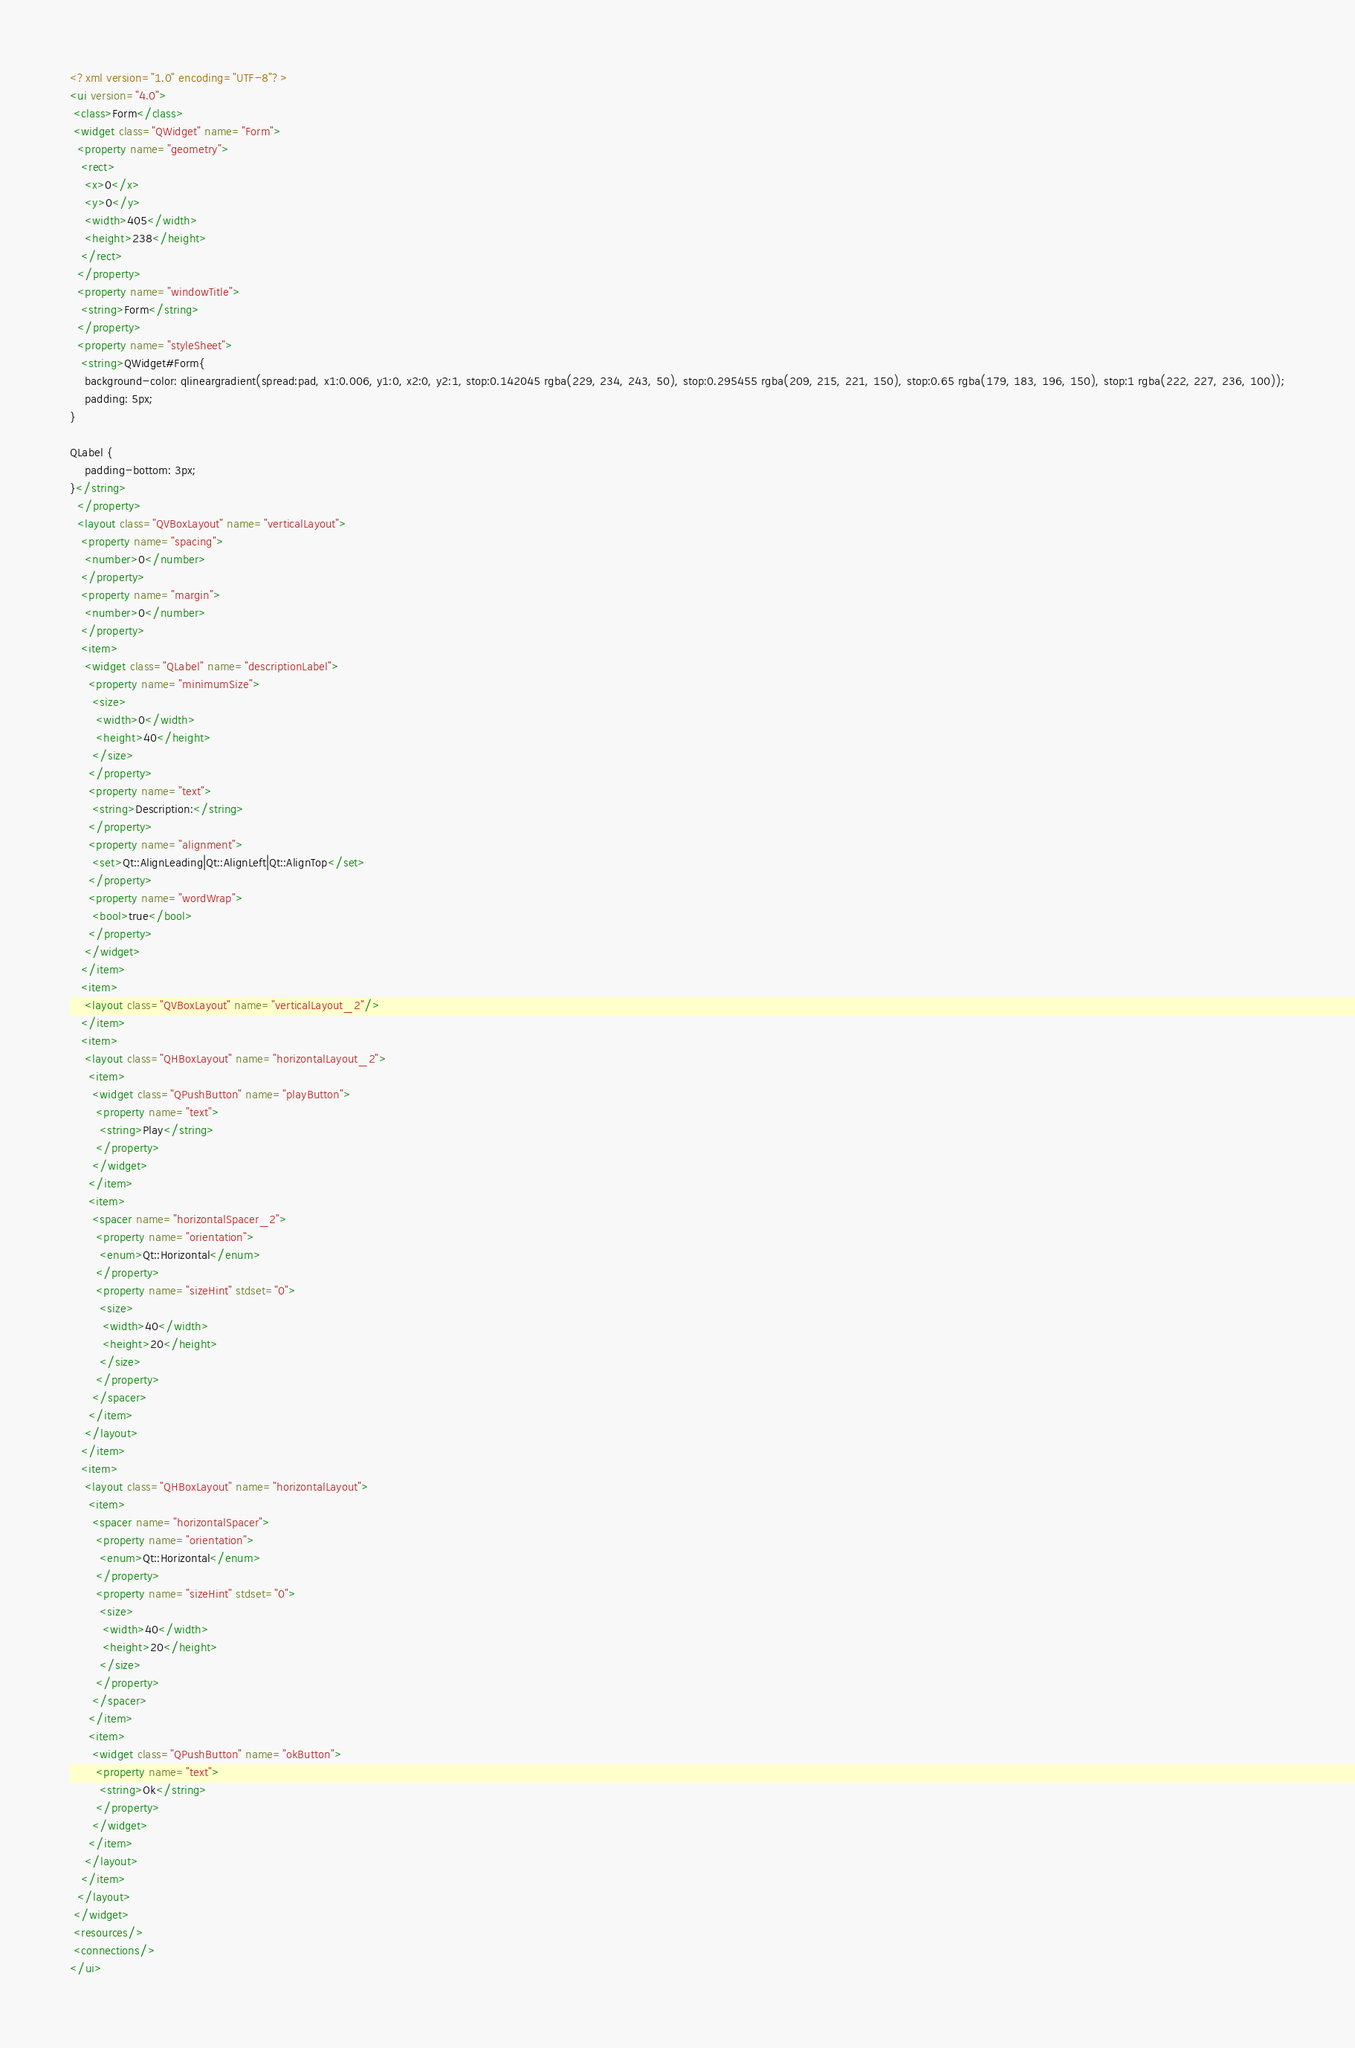Convert code to text. <code><loc_0><loc_0><loc_500><loc_500><_XML_><?xml version="1.0" encoding="UTF-8"?>
<ui version="4.0">
 <class>Form</class>
 <widget class="QWidget" name="Form">
  <property name="geometry">
   <rect>
    <x>0</x>
    <y>0</y>
    <width>405</width>
    <height>238</height>
   </rect>
  </property>
  <property name="windowTitle">
   <string>Form</string>
  </property>
  <property name="styleSheet">
   <string>QWidget#Form{
	background-color: qlineargradient(spread:pad, x1:0.006, y1:0, x2:0, y2:1, stop:0.142045 rgba(229, 234, 243, 50), stop:0.295455 rgba(209, 215, 221, 150), stop:0.65 rgba(179, 183, 196, 150), stop:1 rgba(222, 227, 236, 100));
	padding: 5px;
}

QLabel {
	padding-bottom: 3px;
}</string>
  </property>
  <layout class="QVBoxLayout" name="verticalLayout">
   <property name="spacing">
    <number>0</number>
   </property>
   <property name="margin">
    <number>0</number>
   </property>
   <item>
    <widget class="QLabel" name="descriptionLabel">
     <property name="minimumSize">
      <size>
       <width>0</width>
       <height>40</height>
      </size>
     </property>
     <property name="text">
      <string>Description:</string>
     </property>
     <property name="alignment">
      <set>Qt::AlignLeading|Qt::AlignLeft|Qt::AlignTop</set>
     </property>
     <property name="wordWrap">
      <bool>true</bool>
     </property>
    </widget>
   </item>
   <item>
    <layout class="QVBoxLayout" name="verticalLayout_2"/>
   </item>
   <item>
    <layout class="QHBoxLayout" name="horizontalLayout_2">
     <item>
      <widget class="QPushButton" name="playButton">
       <property name="text">
        <string>Play</string>
       </property>
      </widget>
     </item>
     <item>
      <spacer name="horizontalSpacer_2">
       <property name="orientation">
        <enum>Qt::Horizontal</enum>
       </property>
       <property name="sizeHint" stdset="0">
        <size>
         <width>40</width>
         <height>20</height>
        </size>
       </property>
      </spacer>
     </item>
    </layout>
   </item>
   <item>
    <layout class="QHBoxLayout" name="horizontalLayout">
     <item>
      <spacer name="horizontalSpacer">
       <property name="orientation">
        <enum>Qt::Horizontal</enum>
       </property>
       <property name="sizeHint" stdset="0">
        <size>
         <width>40</width>
         <height>20</height>
        </size>
       </property>
      </spacer>
     </item>
     <item>
      <widget class="QPushButton" name="okButton">
       <property name="text">
        <string>Ok</string>
       </property>
      </widget>
     </item>
    </layout>
   </item>
  </layout>
 </widget>
 <resources/>
 <connections/>
</ui>
</code> 